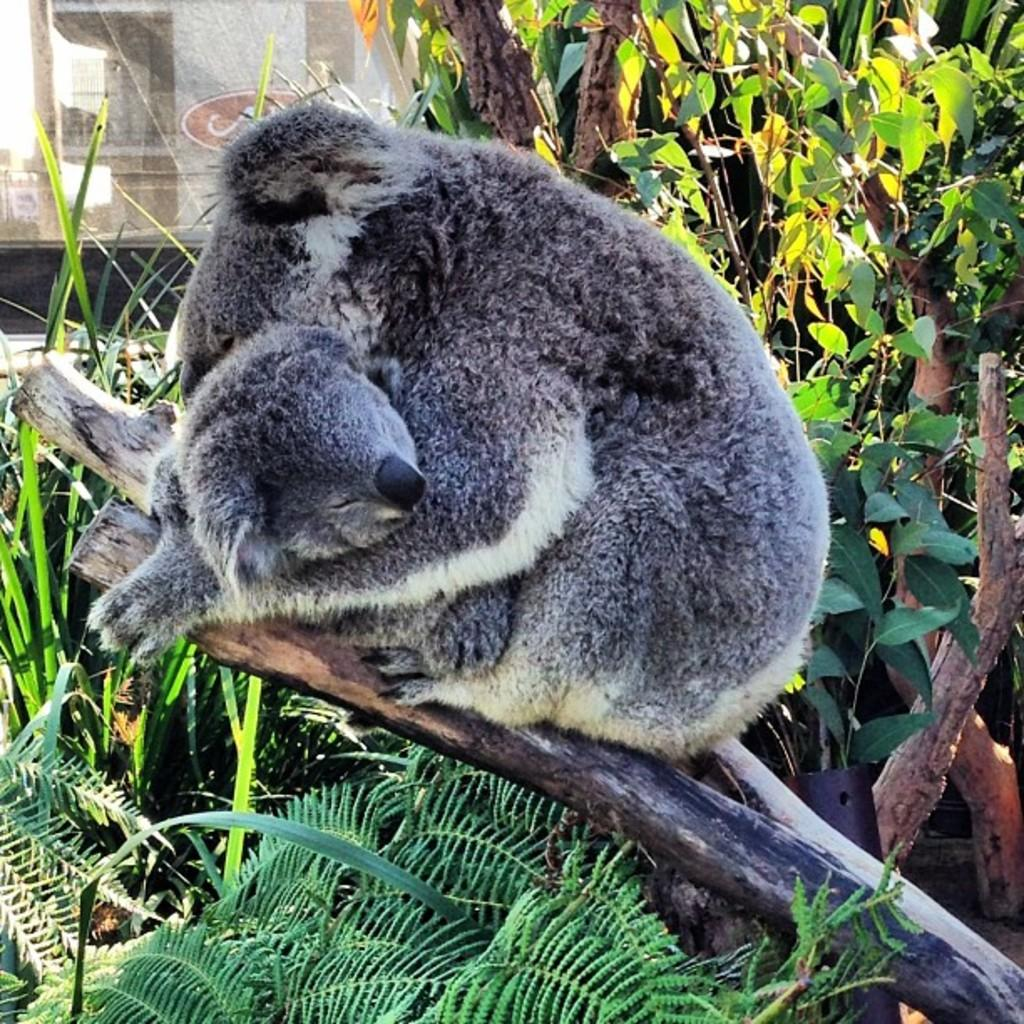What are the two animals on the wooden log in the image? There are two animals on a wooden log in the image, but their specific species cannot be determined from the facts provided. What can be seen in the background of the image? There is a group of trees and a building visible in the background of the image. What is visible at the top of the image? The sky is visible in the background of the image. How many ducks are sitting on the bit of wood in the image? There is no mention of ducks or a bit of wood in the image. The facts provided only mention two animals on a wooden log, but their specific species cannot be determined. 